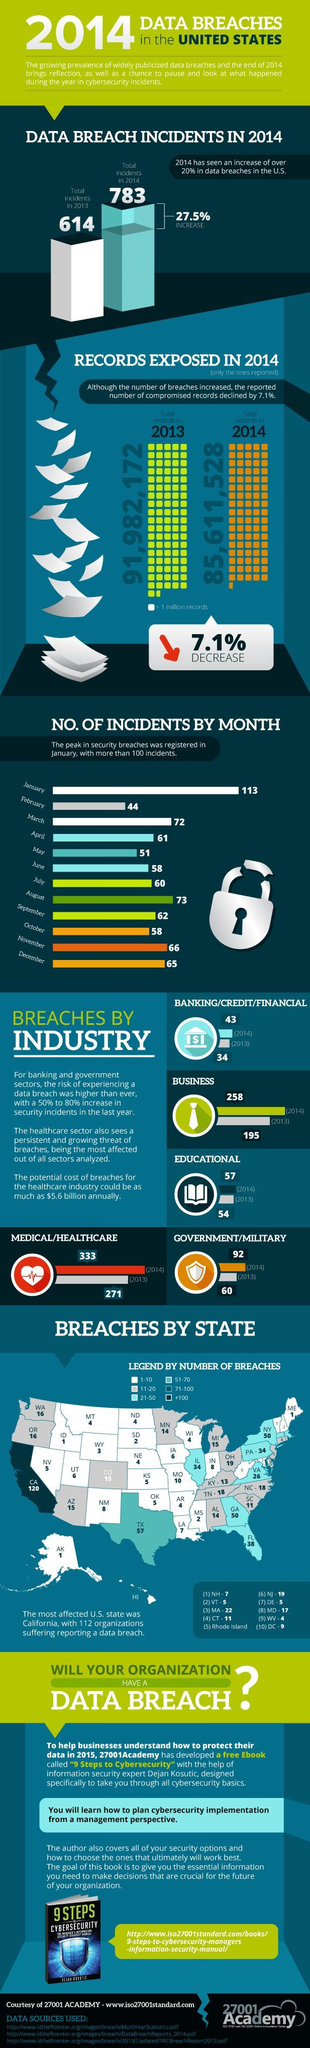How many data breach incidents were reported in 2013?
Answer the question with a short phrase. 614 How many states have number of reported data breach incidents above 51? 2 How many months have number of reported incidents above 100? 1 Which was the only month where the number of incidents reported was below 50? February In the image, which year shows a lower number of data breach incidents? 2013 How many data breach incidents were reported by the Government/Military in 2014? 92 For how many months was the number of reported incidents less than 60? 4 In which month was the second highest number of incidents reported? August Which year shows a higher reported number of compromised records? 2013 Which sector reported 333 data breach incidents in 2014? Medical/healthcare 